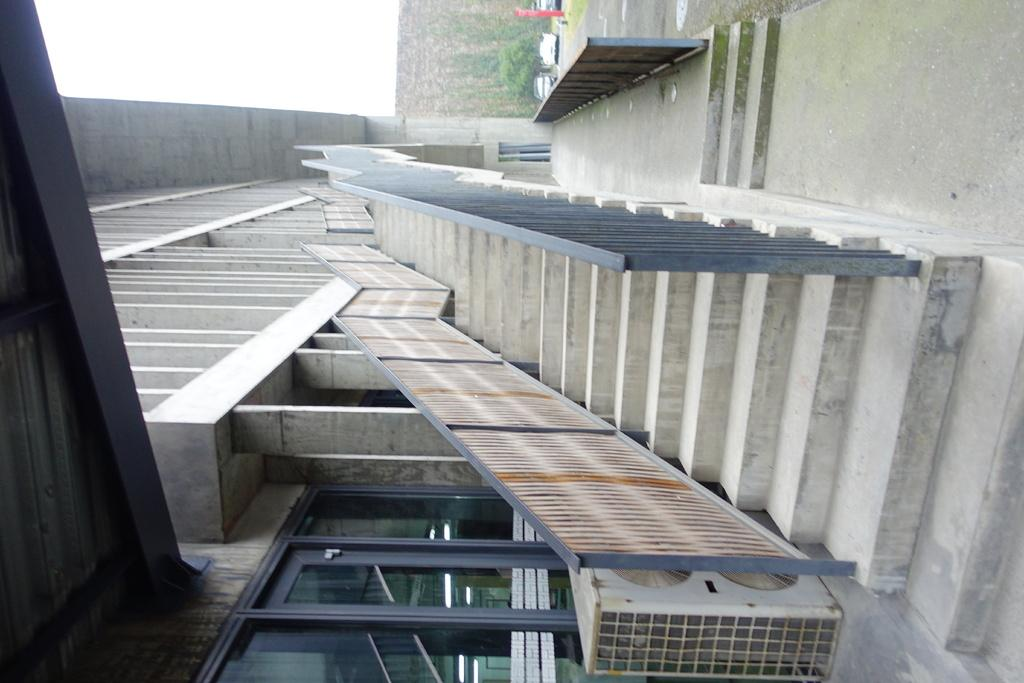Where was the image taken? The image was clicked outside. What can be seen in the middle of the image? There are stairs in the middle of the image. What structure is located at the bottom of the image? There is a building at the bottom of the image. What type of vehicles are visible at the top of the image? There are cars at the top of the image. What type of pollution can be seen in the image? There is no visible pollution in the image. Can you describe the squirrel sitting on the stairs in the image? There is no squirrel present in the image. 